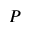Convert formula to latex. <formula><loc_0><loc_0><loc_500><loc_500>P</formula> 